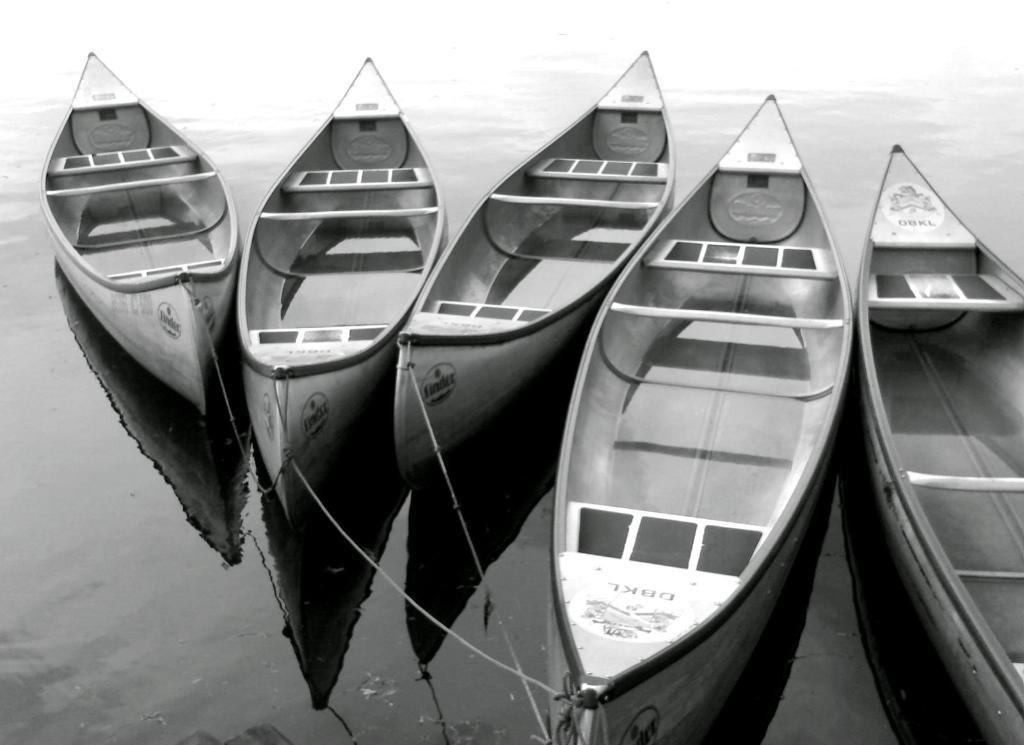Could you give a brief overview of what you see in this image? In this image we can see some boats, four boats with threads on the water, one boat on the water on the right side of the image truncated and some text with images on the boats. 